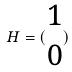<formula> <loc_0><loc_0><loc_500><loc_500>H = ( \begin{matrix} 1 \\ 0 \end{matrix} )</formula> 